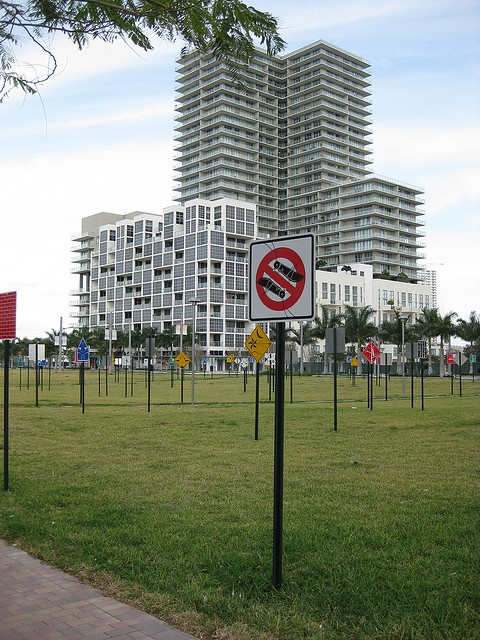Describe the objects in this image and their specific colors. I can see various objects in this image with different colors. 